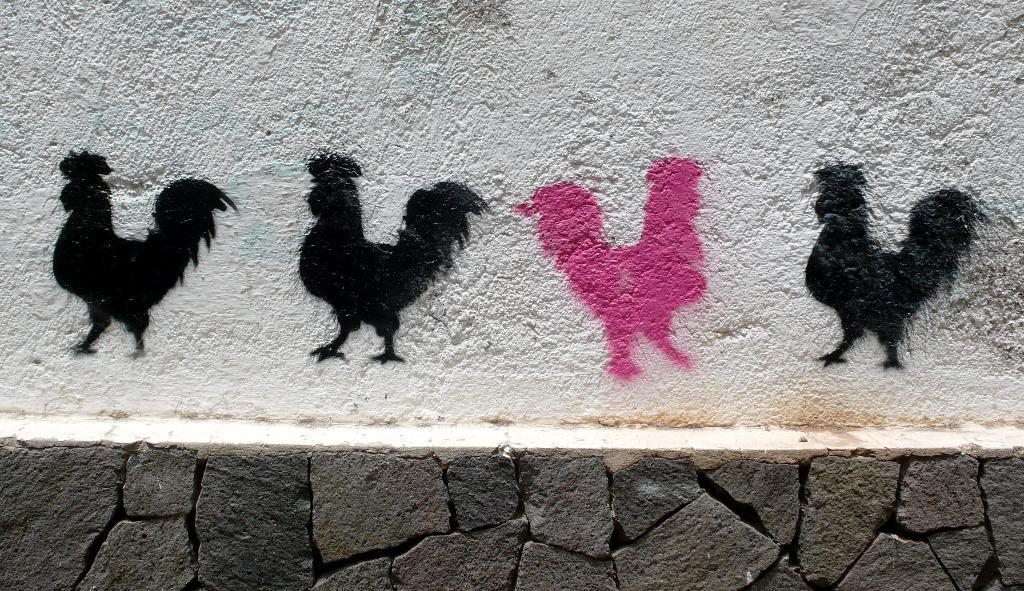What type of artwork is displayed on the wall in the image? There are paintings of hens on the wall in the image. What kind of natural feature can be seen in the image? There is a rock wall in the image. How many men are using a rake in the image? There are no men or rakes present in the image. What historical event is depicted in the image? The image does not depict any historical event; it features paintings of hens and a rock wall. 